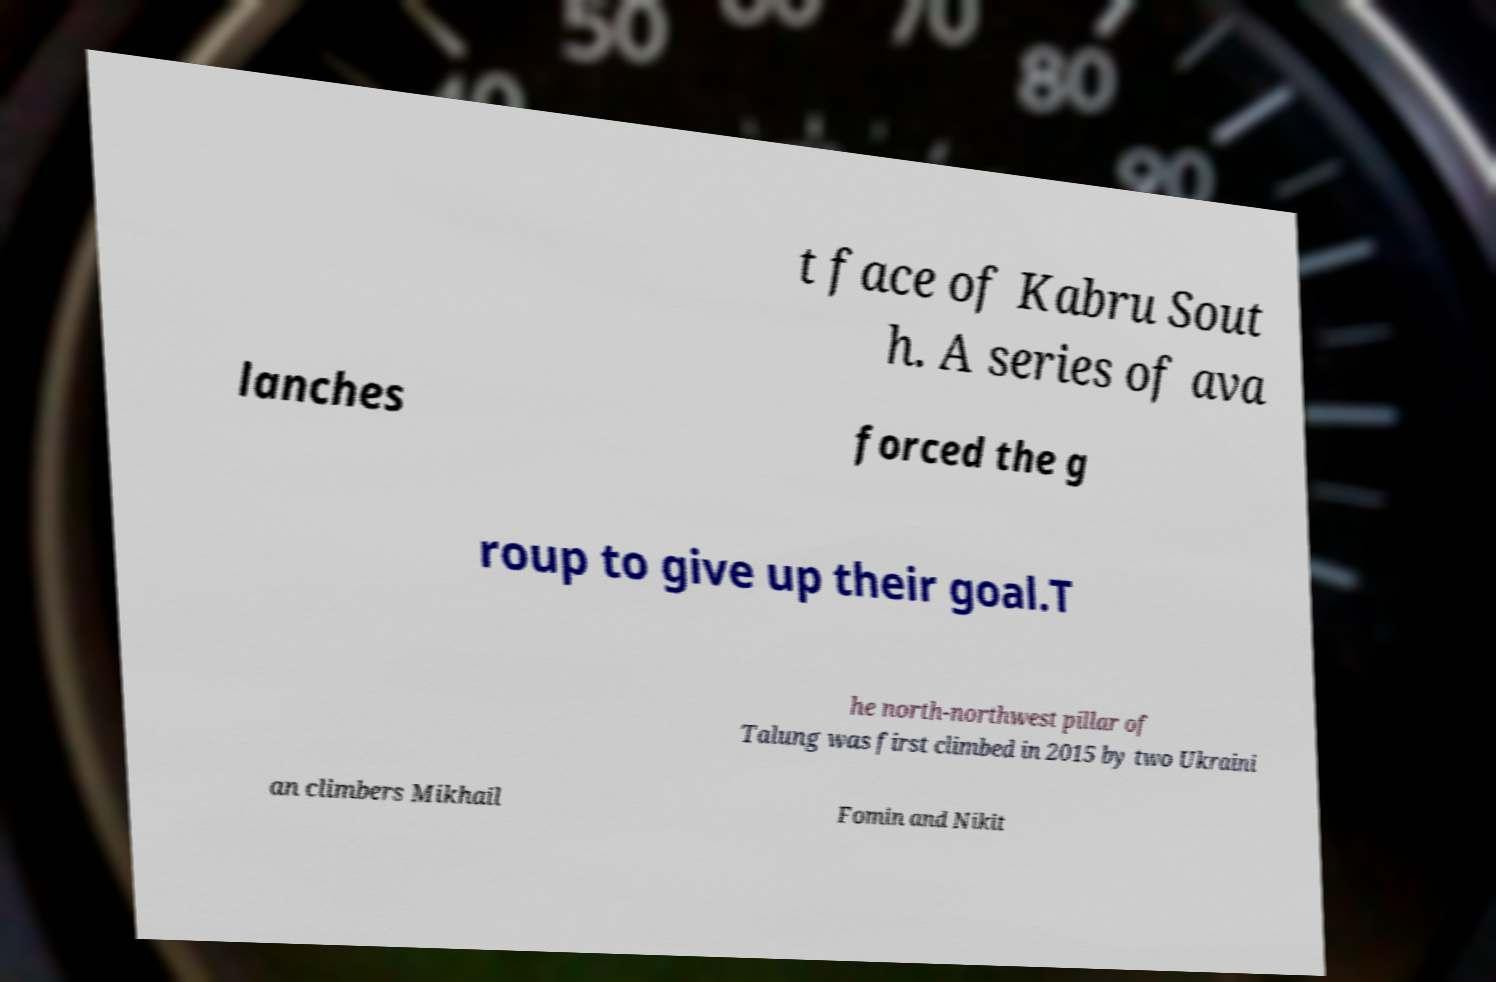Can you accurately transcribe the text from the provided image for me? t face of Kabru Sout h. A series of ava lanches forced the g roup to give up their goal.T he north-northwest pillar of Talung was first climbed in 2015 by two Ukraini an climbers Mikhail Fomin and Nikit 